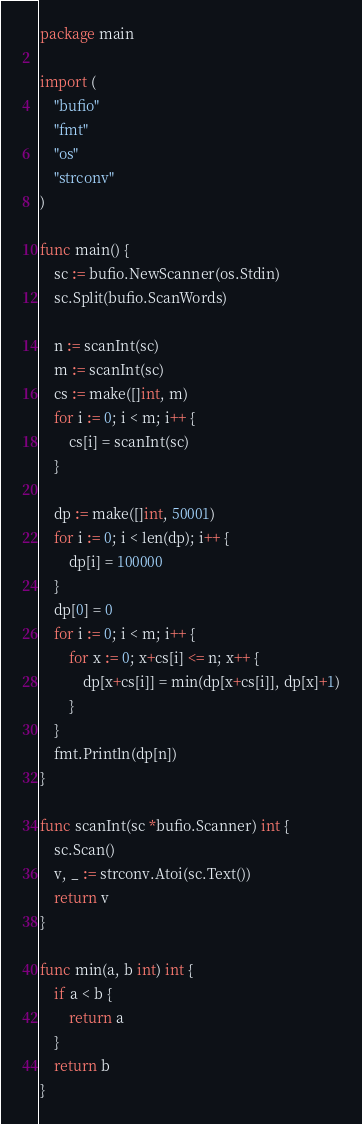<code> <loc_0><loc_0><loc_500><loc_500><_Go_>package main

import (
	"bufio"
	"fmt"
	"os"
	"strconv"
)

func main() {
	sc := bufio.NewScanner(os.Stdin)
	sc.Split(bufio.ScanWords)

	n := scanInt(sc)
	m := scanInt(sc)
	cs := make([]int, m)
	for i := 0; i < m; i++ {
		cs[i] = scanInt(sc)
	}

	dp := make([]int, 50001)
	for i := 0; i < len(dp); i++ {
		dp[i] = 100000
	}
	dp[0] = 0
	for i := 0; i < m; i++ {
		for x := 0; x+cs[i] <= n; x++ {
			dp[x+cs[i]] = min(dp[x+cs[i]], dp[x]+1)
		}
	}
	fmt.Println(dp[n])
}

func scanInt(sc *bufio.Scanner) int {
	sc.Scan()
	v, _ := strconv.Atoi(sc.Text())
	return v
}

func min(a, b int) int {
	if a < b {
		return a
	}
	return b
}

</code> 